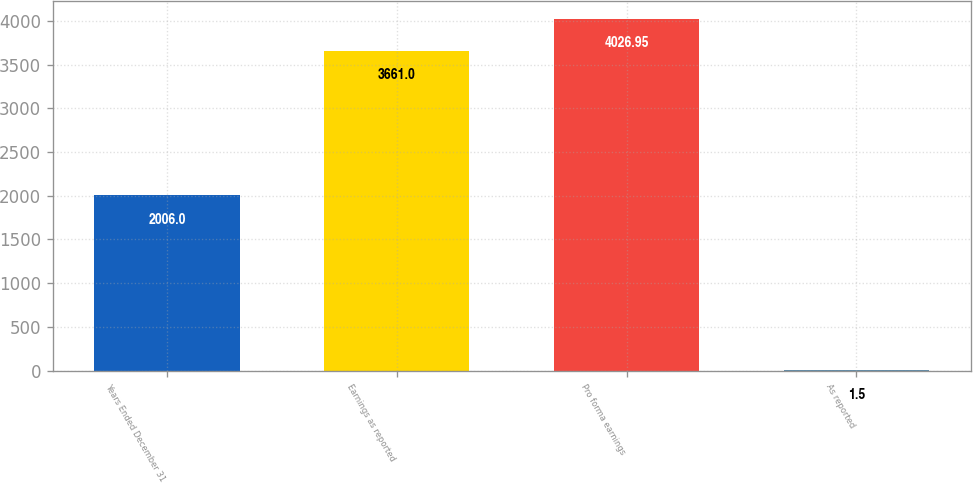<chart> <loc_0><loc_0><loc_500><loc_500><bar_chart><fcel>Years Ended December 31<fcel>Earnings as reported<fcel>Pro forma earnings<fcel>As reported<nl><fcel>2006<fcel>3661<fcel>4026.95<fcel>1.5<nl></chart> 